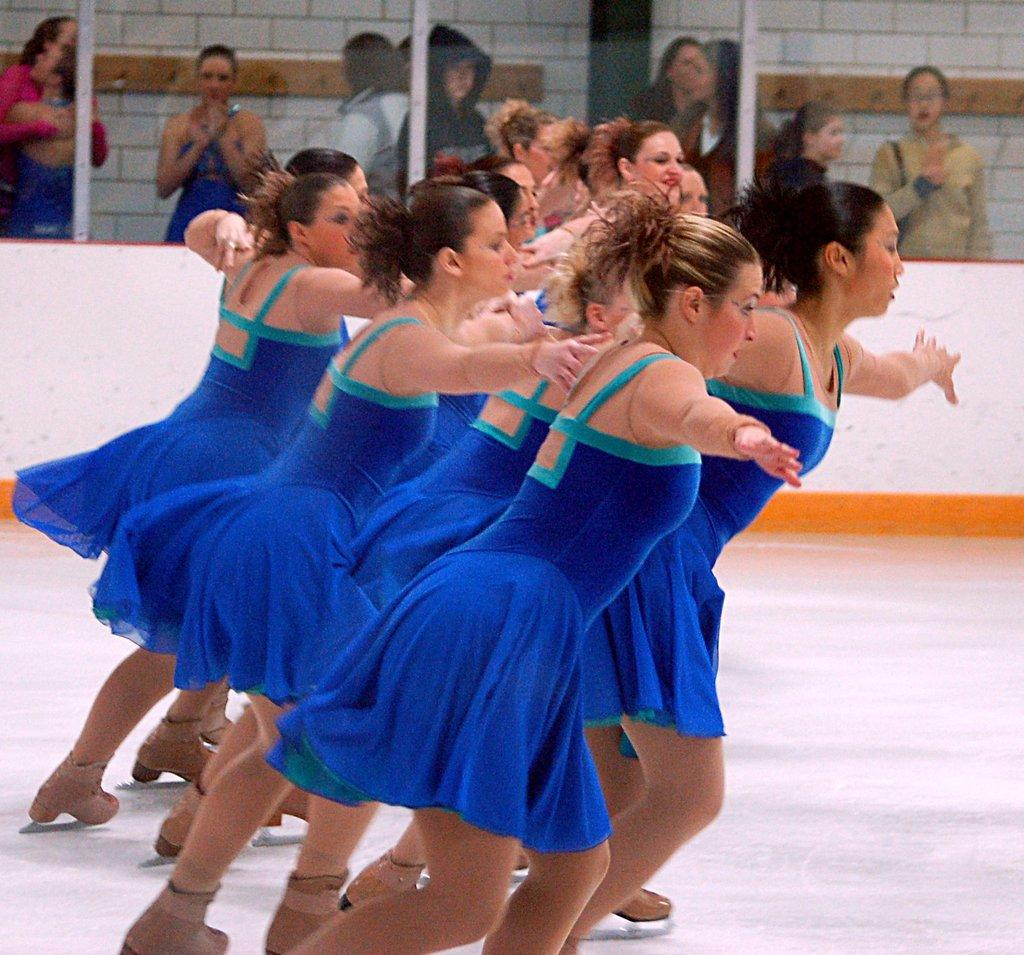What are the women in the image doing? There is a group of women dancing in the image. Can you describe any architectural features in the image? The image appears to show a glass door. What is happening behind the glass door in the image? There are people standing behind the glass door in the image. What type of turkey can be seen in the cemetery in the image? There is no turkey or cemetery present in the image; it features a group of women dancing and a glass door with people standing behind it. 